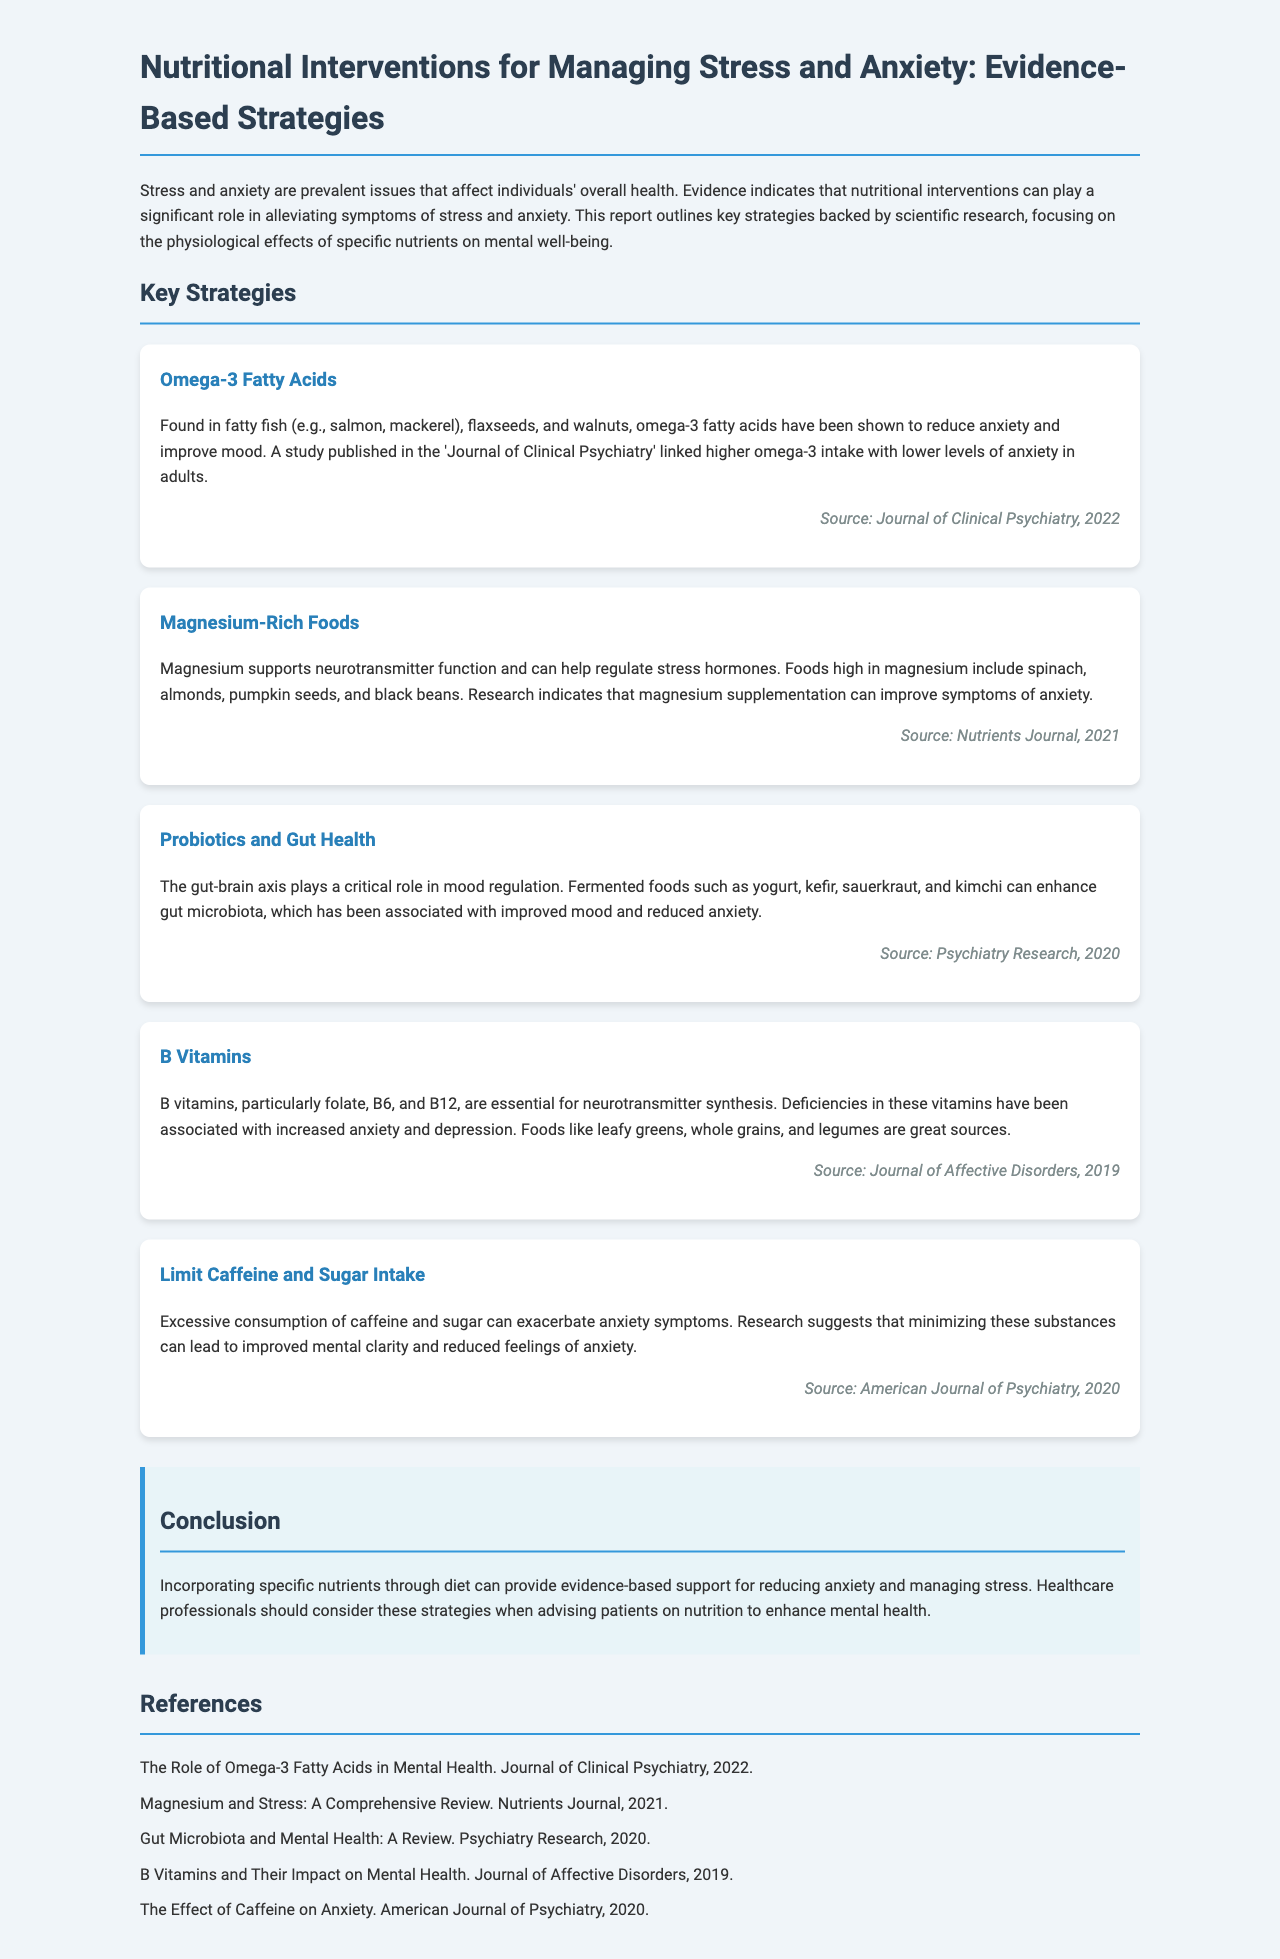What are omega-3 fatty acids found in? Omega-3 fatty acids are found in fatty fish (e.g., salmon, mackerel), flaxseeds, and walnuts.
Answer: Fatty fish, flaxseeds, walnuts What role does magnesium play in the body? Magnesium supports neurotransmitter function and can help regulate stress hormones.
Answer: Supports neurotransmitter function Which foods can enhance gut microbiota? Fermented foods such as yogurt, kefir, sauerkraut, and kimchi can enhance gut microbiota.
Answer: Yogurt, kefir, sauerkraut, kimchi What vitamins are essential for neurotransmitter synthesis? B vitamins, particularly folate, B6, and B12 are essential for neurotransmitter synthesis.
Answer: Folate, B6, B12 What can excessive consumption of caffeine and sugar cause? Excessive consumption of caffeine and sugar can exacerbate anxiety symptoms.
Answer: Exacerbate anxiety symptoms Why should healthcare professionals consider dietary strategies for mental health? Healthcare professionals should consider these strategies when advising patients on nutrition to enhance mental health.
Answer: Enhance mental health Which journal published research on omega-3 intake and anxiety? The study linking higher omega-3 intake with lower levels of anxiety was published in the Journal of Clinical Psychiatry.
Answer: Journal of Clinical Psychiatry In which year was magnesium supplementation research published? Research indicating that magnesium supplementation can improve symptoms of anxiety was published in 2021.
Answer: 2021 